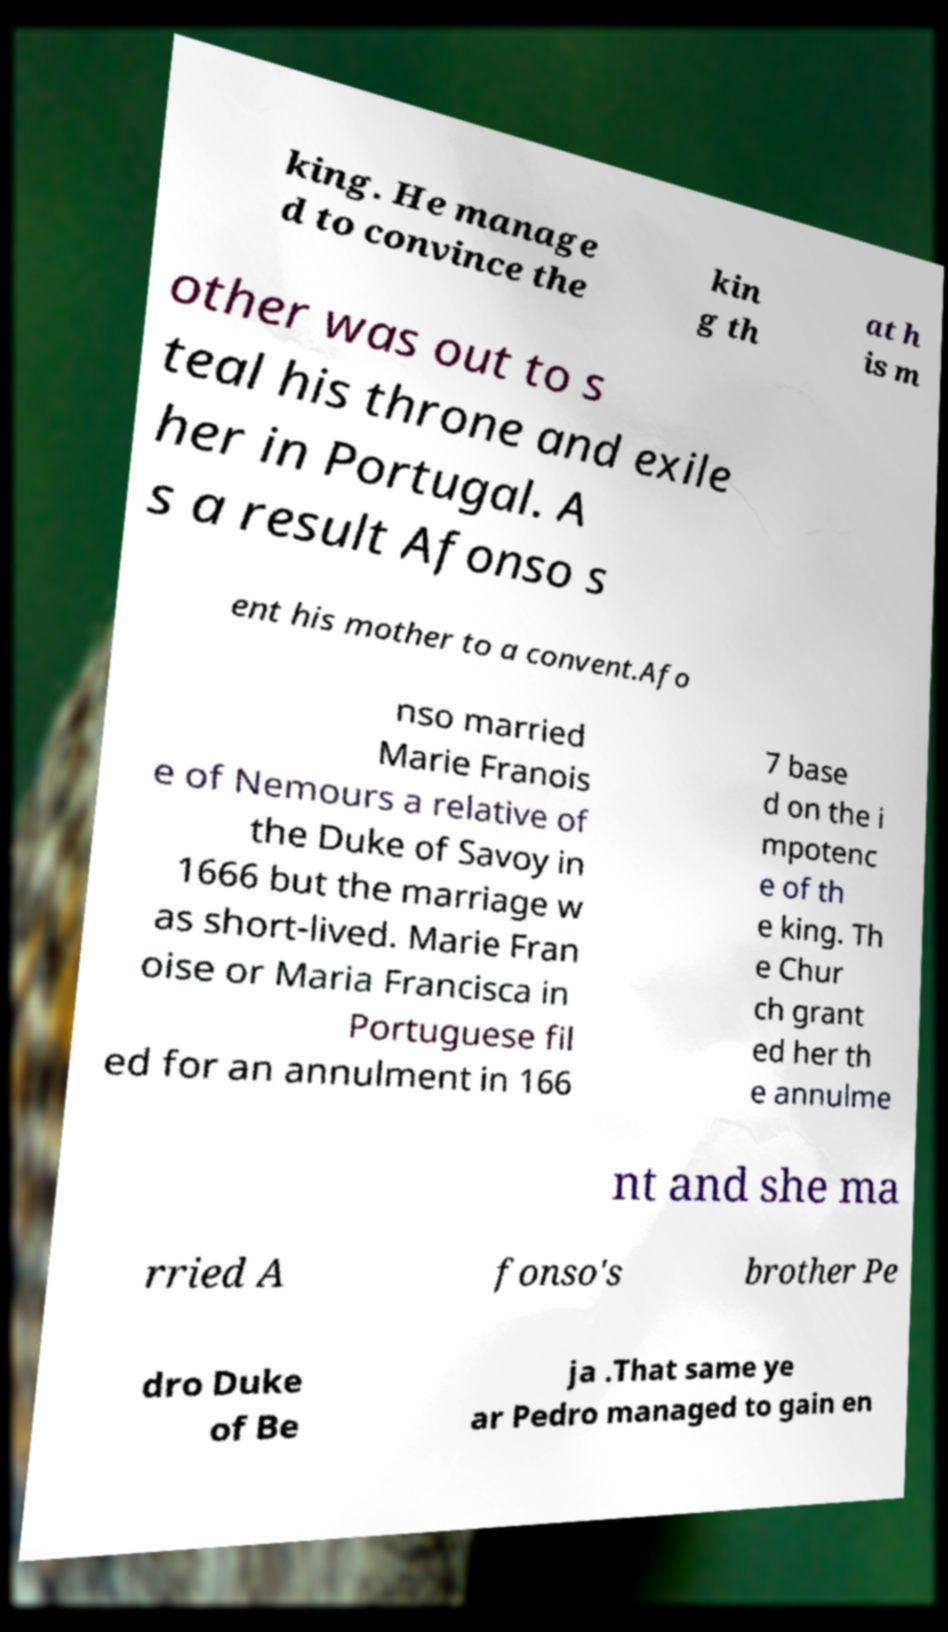Can you read and provide the text displayed in the image?This photo seems to have some interesting text. Can you extract and type it out for me? king. He manage d to convince the kin g th at h is m other was out to s teal his throne and exile her in Portugal. A s a result Afonso s ent his mother to a convent.Afo nso married Marie Franois e of Nemours a relative of the Duke of Savoy in 1666 but the marriage w as short-lived. Marie Fran oise or Maria Francisca in Portuguese fil ed for an annulment in 166 7 base d on the i mpotenc e of th e king. Th e Chur ch grant ed her th e annulme nt and she ma rried A fonso's brother Pe dro Duke of Be ja .That same ye ar Pedro managed to gain en 